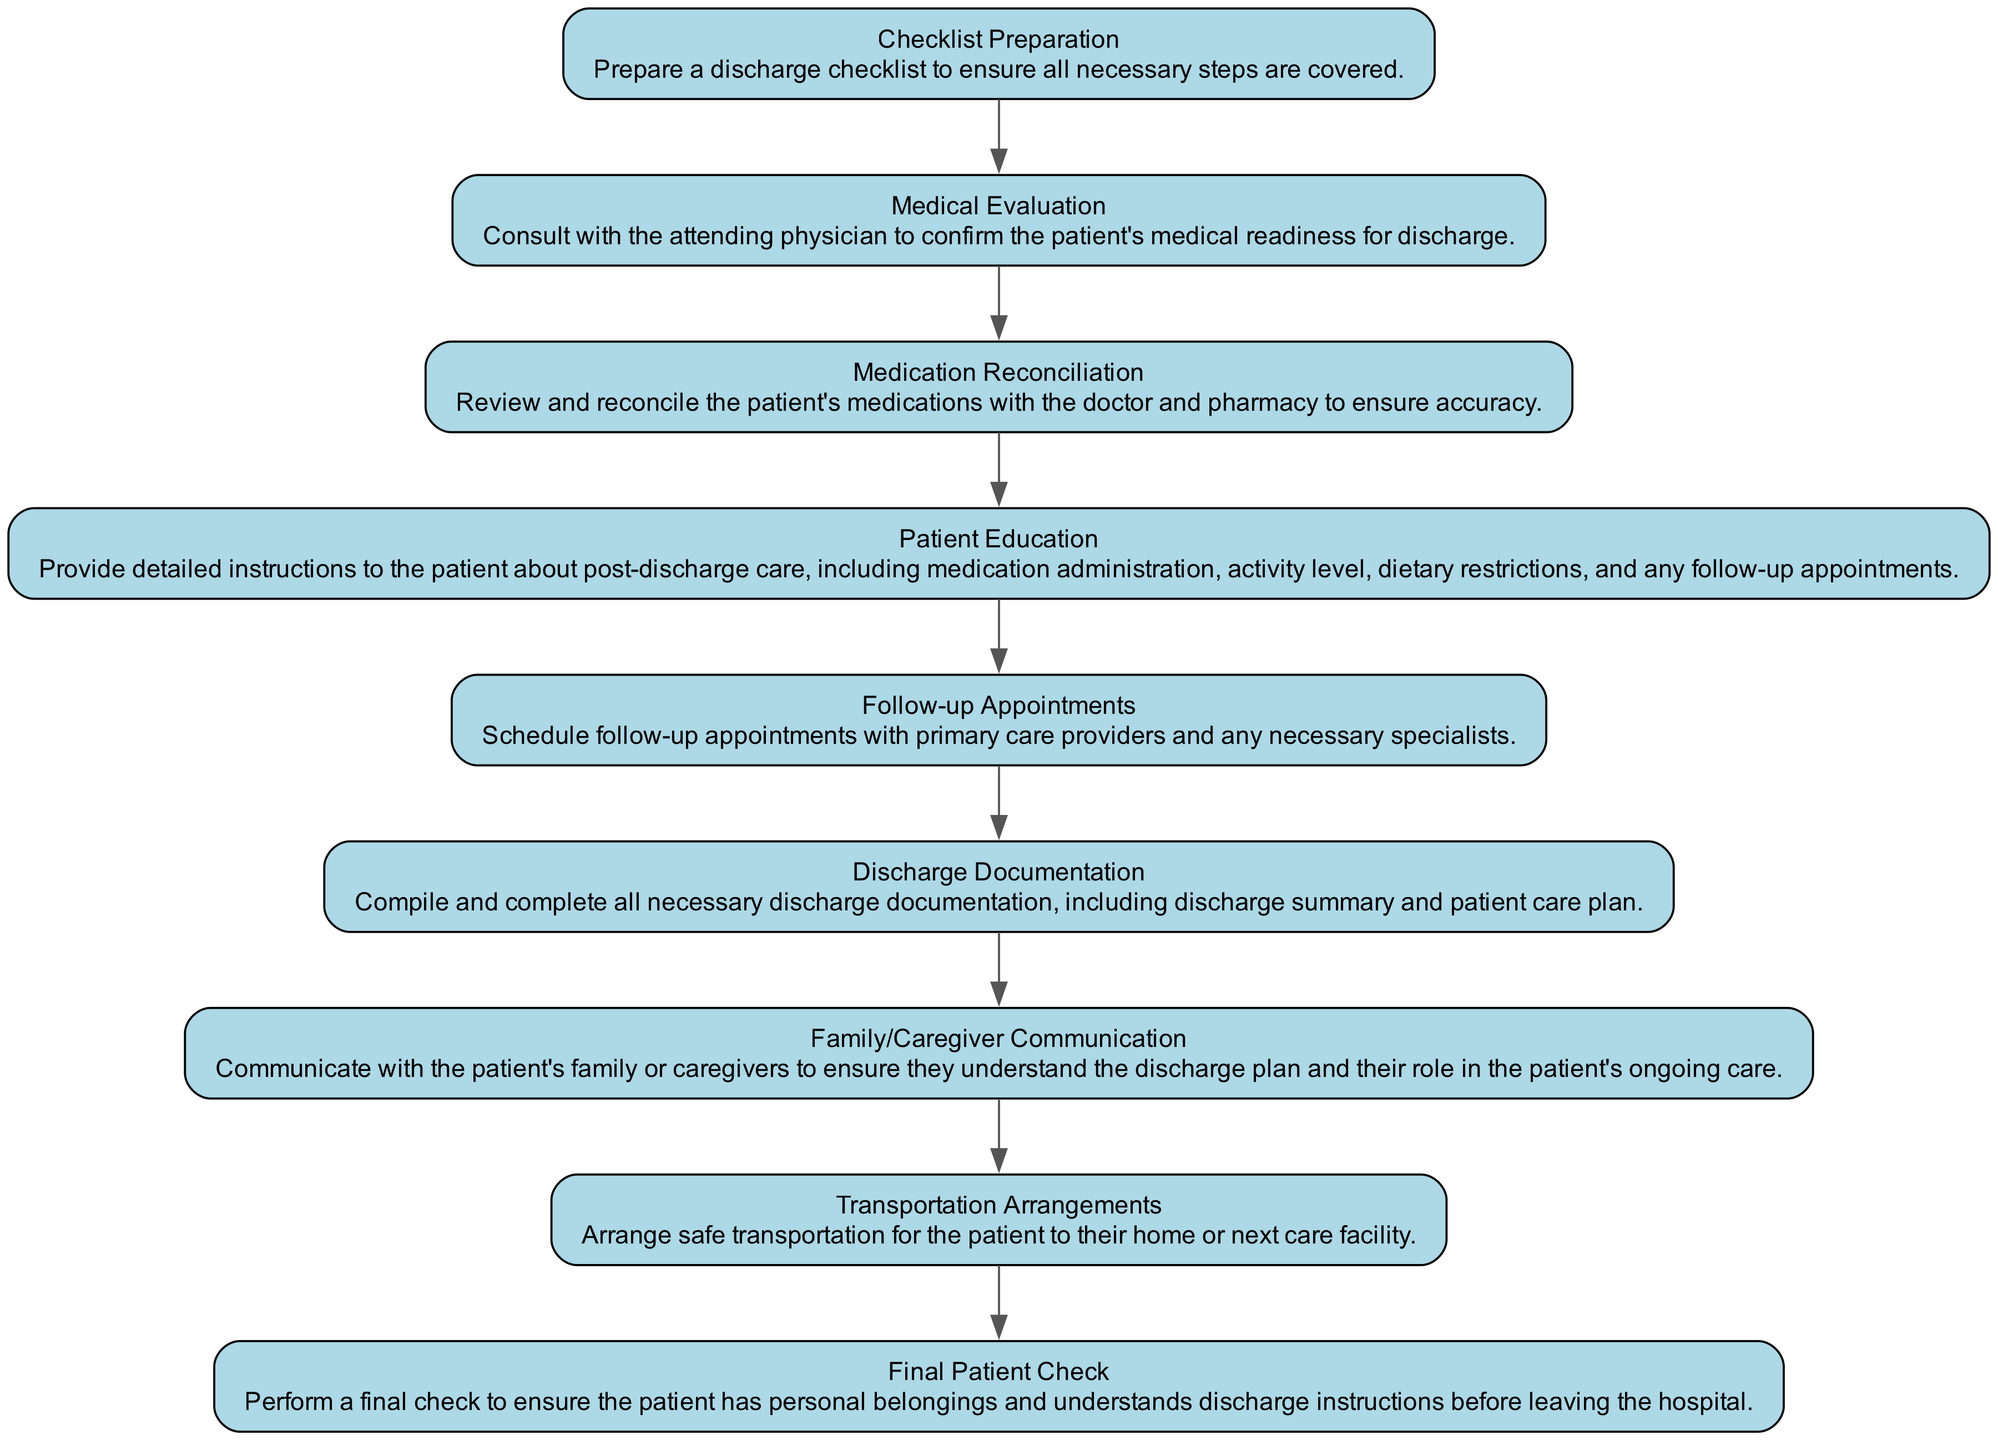What is the first step in the discharge process? The first step is "Checklist Preparation," as it is the initial node in the diagram and sets the stage for the entire discharge process.
Answer: Checklist Preparation How many steps are there in total for managing patient discharge? There are nine steps in total, which can be counted by identifying all the nodes present in the flow chart.
Answer: Nine What comes after "Medical Evaluation"? After "Medical Evaluation," the next step is "Medication Reconciliation," which follows directly based on the edges connecting the nodes in the diagram.
Answer: Medication Reconciliation Which step involves patient care education? The step that involves patient care education is "Patient Education," where detailed instructions are provided to the patient regarding their post-discharge care.
Answer: Patient Education What is required before "Final Patient Check"? Before "Final Patient Check," the steps that need to be completed are "Transportation Arrangements" and "Discharge Documentation," as they directly precede the final check in the sequence of the flow chart.
Answer: Transportation Arrangements, Discharge Documentation How does family involvement fit into the discharge process? Family involvement is addressed in the "Family/Caregiver Communication" step, which ensures that the family or caregivers understand the discharge plan and their role in the patient's ongoing care.
Answer: Family/Caregiver Communication Which step involves a consultation with the attending physician? The step that involves a consultation with the attending physician is "Medical Evaluation," where the physician confirms the patient's readiness for discharge.
Answer: Medical Evaluation What is the last step before the patient leaves the hospital? The last step before the patient leaves the hospital is "Final Patient Check," where all personal belongings are confirmed and discharge instructions are reviewed.
Answer: Final Patient Check Which task ensures the patient has the correct medications? The task that ensures the patient has the correct medications is "Medication Reconciliation," which reviews and confirms the medications with the doctor and pharmacy.
Answer: Medication Reconciliation 